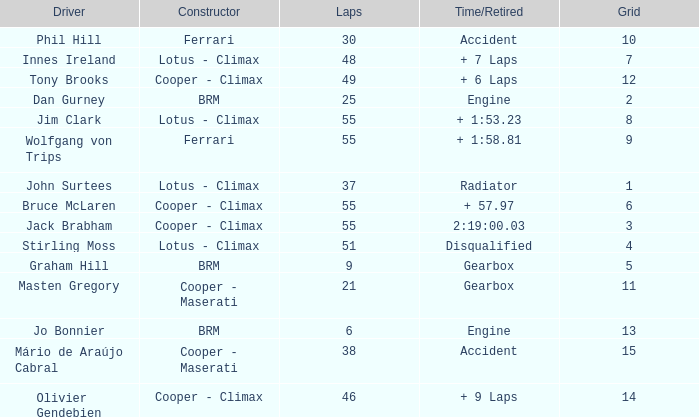Tell me the laps for 3 grids 55.0. 